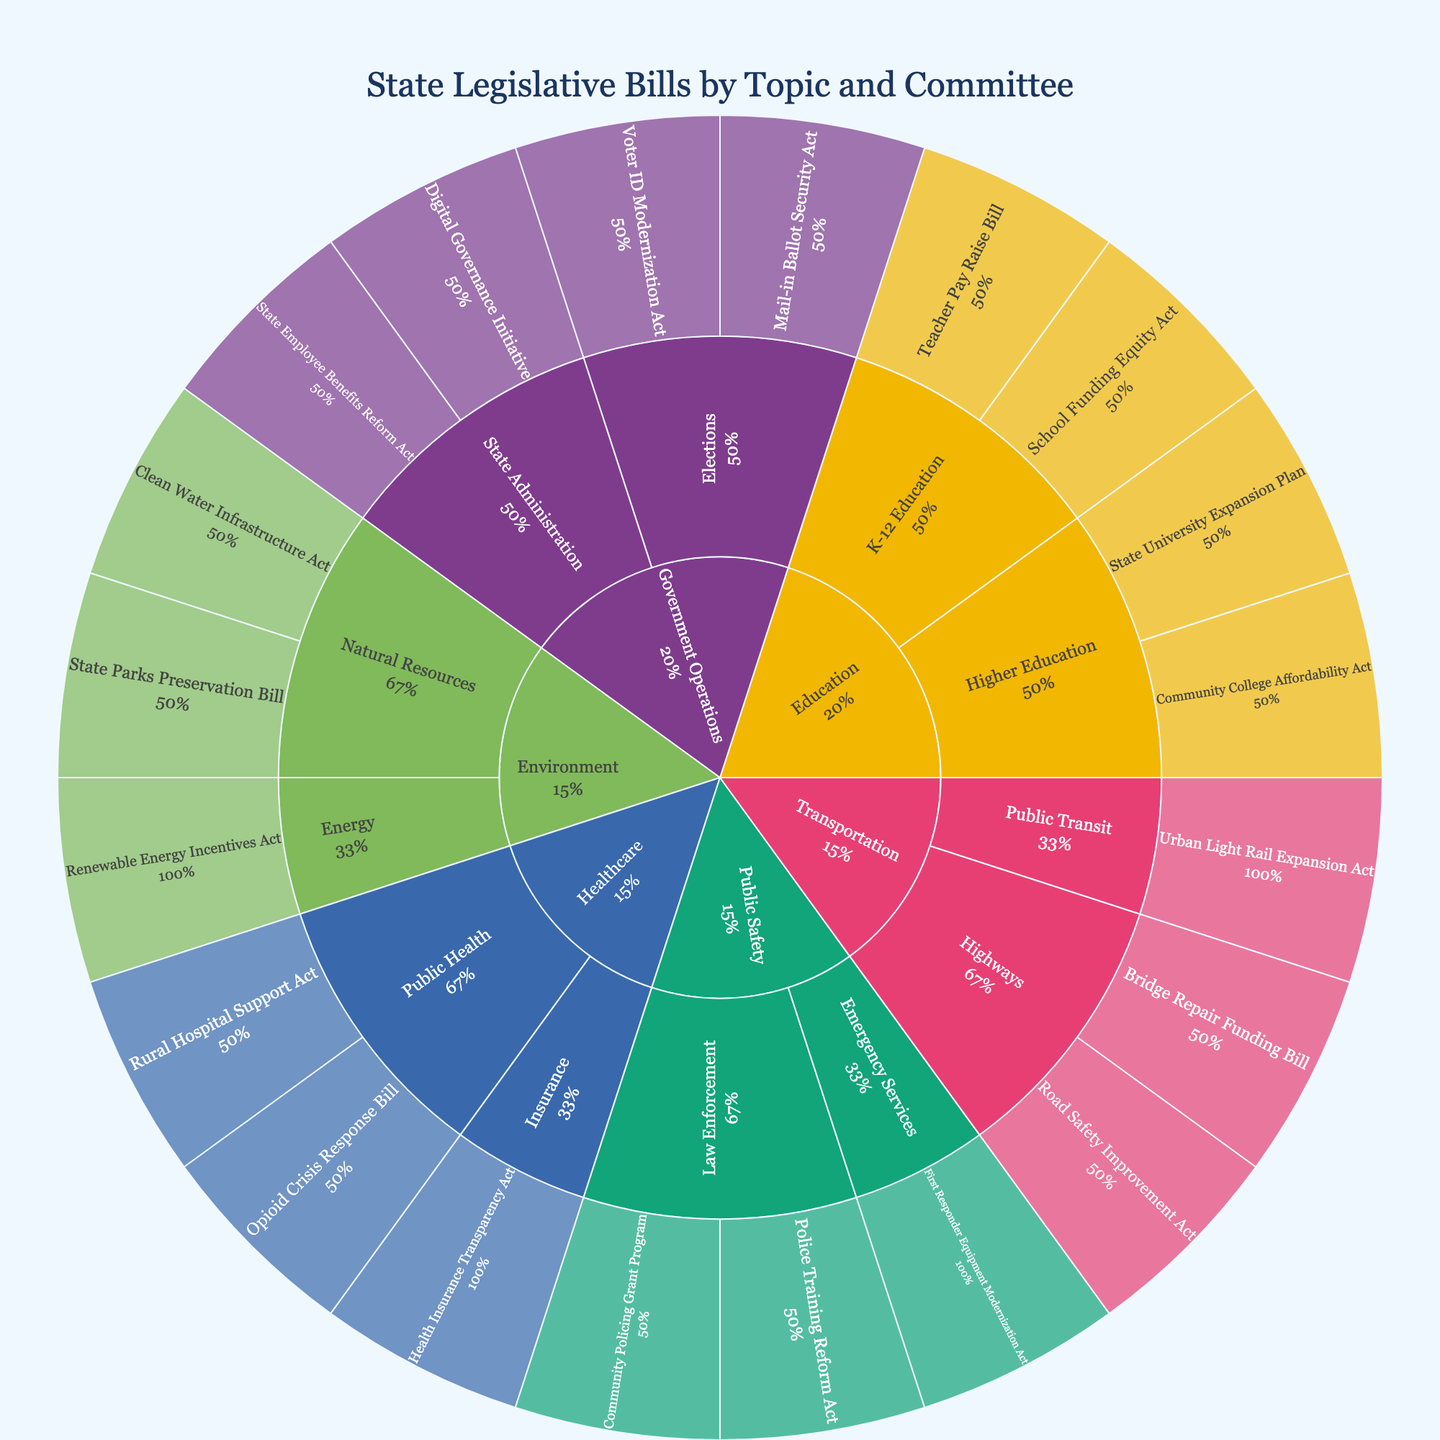What's the title of the figure? The title is usually displayed at the top of the figure layout and provides a concise description of what the figure represents. In this case, the title clearly describes the content.
Answer: State Legislative Bills by Topic and Committee Which topic has the most legislative bills proposed? To determine this, look at the segments in the innermost ring of the sunburst plot and compare their sizes. The largest segment represents the topic with the most bills.
Answer: Government Operations Identify two bills under the "Healthcare" topic. Look for the segment labeled "Healthcare" in the inner ring, then follow it outward to identify the bills listed under it.
Answer: Rural Hospital Support Act, Opioid Crisis Response Bill How many committees are under the "Education" topic? Find the "Education" segment on the inner ring and count the immediate next ring segments representing the committees under it.
Answer: 2 Which committee has the "Urban Light Rail Expansion Act" bill? Trace from "Transportation" topic to its sub-segments and find the specific bill "Urban Light Rail Expansion Act" to identify its committee.
Answer: Public Transit Compare the number of bills between "Natural Resources" and "Public Health". Which has more? Look at the segments under the "Environment" and "Healthcare" topics and count the bills under each respective committee. Compare the counts.
Answer: Natural Resources If a new bill is proposed under the "K-12 Education" committee, how many bills would that make under this committee? Start with the current count of segments for bills under "K-12 Education" and add one for the new bill.
Answer: 3 What percentage of the "Public Safety" bills are under the "Law Enforcement" committee? Identify the total number of bills under "Public Safety", then count the number under "Law Enforcement" and calculate the percentage (Law Enforcement count divided by total Public Safety count, times 100).
Answer: 66.7% How are bills in the "Transportation" topic distributed among its committees? Find "Transportation" in the inner ring, trace its sub-segments, and note how many bills are listed under each committee within this topic.
Answer: Highways: 2, Public Transit: 1 Which topic contains the "First Responder Equipment Modernization Act"? Locate the specific bill in the outermost ring and trace backward to find the corresponding topic segment in the inner ring.
Answer: Public Safety 